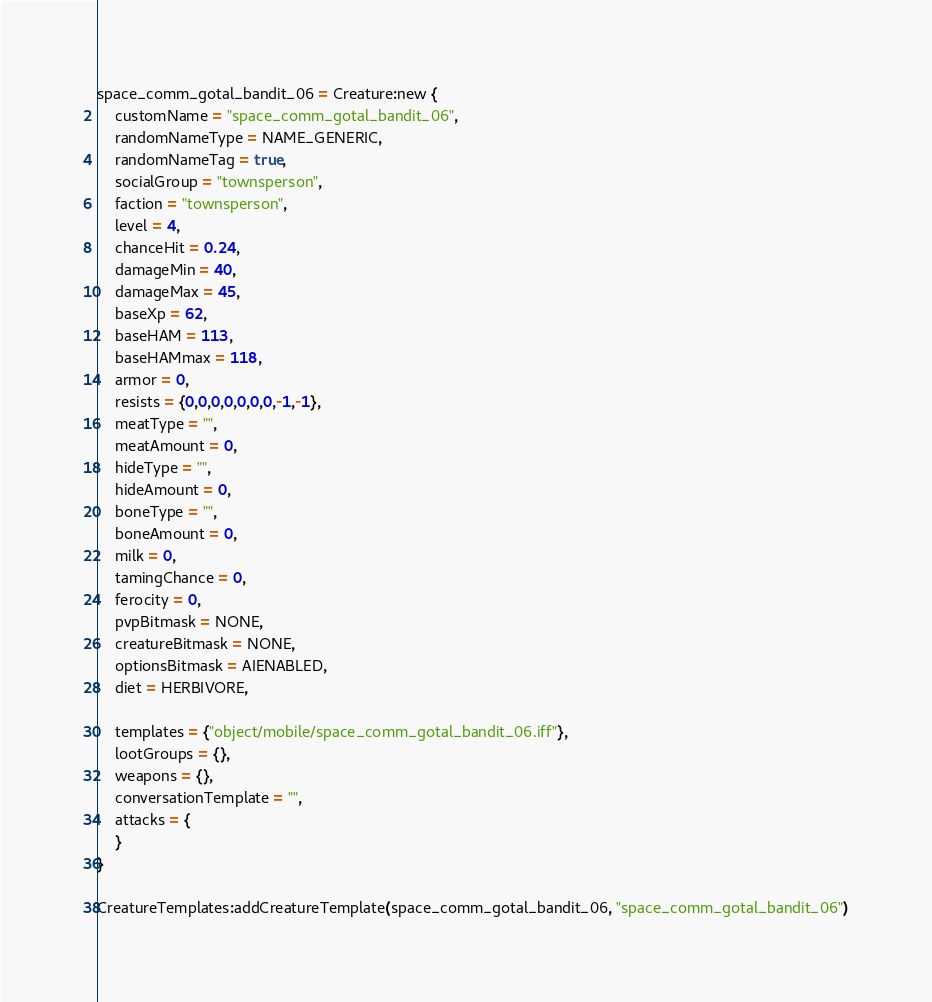<code> <loc_0><loc_0><loc_500><loc_500><_Lua_>space_comm_gotal_bandit_06 = Creature:new {
	customName = "space_comm_gotal_bandit_06",
	randomNameType = NAME_GENERIC,
	randomNameTag = true,
	socialGroup = "townsperson",
	faction = "townsperson",
	level = 4,
	chanceHit = 0.24,
	damageMin = 40,
	damageMax = 45,
	baseXp = 62,
	baseHAM = 113,
	baseHAMmax = 118,
	armor = 0,
	resists = {0,0,0,0,0,0,0,-1,-1},
	meatType = "",
	meatAmount = 0,
	hideType = "",
	hideAmount = 0,
	boneType = "",
	boneAmount = 0,
	milk = 0,
	tamingChance = 0,
	ferocity = 0,
	pvpBitmask = NONE,
	creatureBitmask = NONE,
	optionsBitmask = AIENABLED,
	diet = HERBIVORE,

	templates = {"object/mobile/space_comm_gotal_bandit_06.iff"},
	lootGroups = {},
	weapons = {},
	conversationTemplate = "",
	attacks = {
	}
}

CreatureTemplates:addCreatureTemplate(space_comm_gotal_bandit_06, "space_comm_gotal_bandit_06")
</code> 